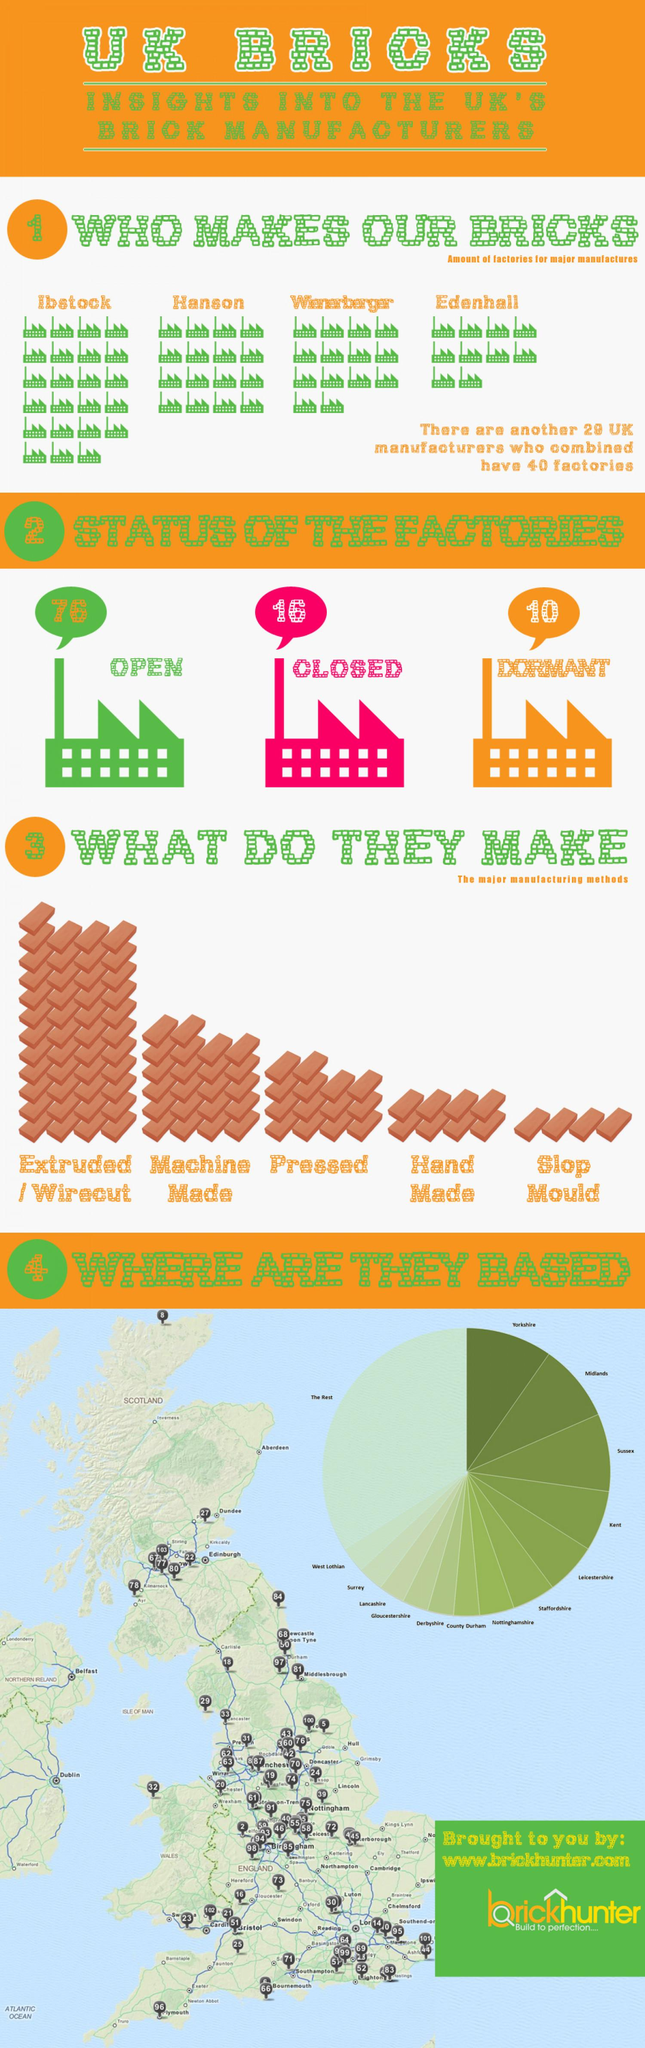Specify some key components in this picture. There are five types of bricks that are manufactured. There are currently 10 dormant factories. The majority of manufacturers are based in Yorkshire. Ibstock is the brick manufacturing company with the largest number of factories. Wienerberger currently has more factories than Hanson, as stated by the previous sentence. 